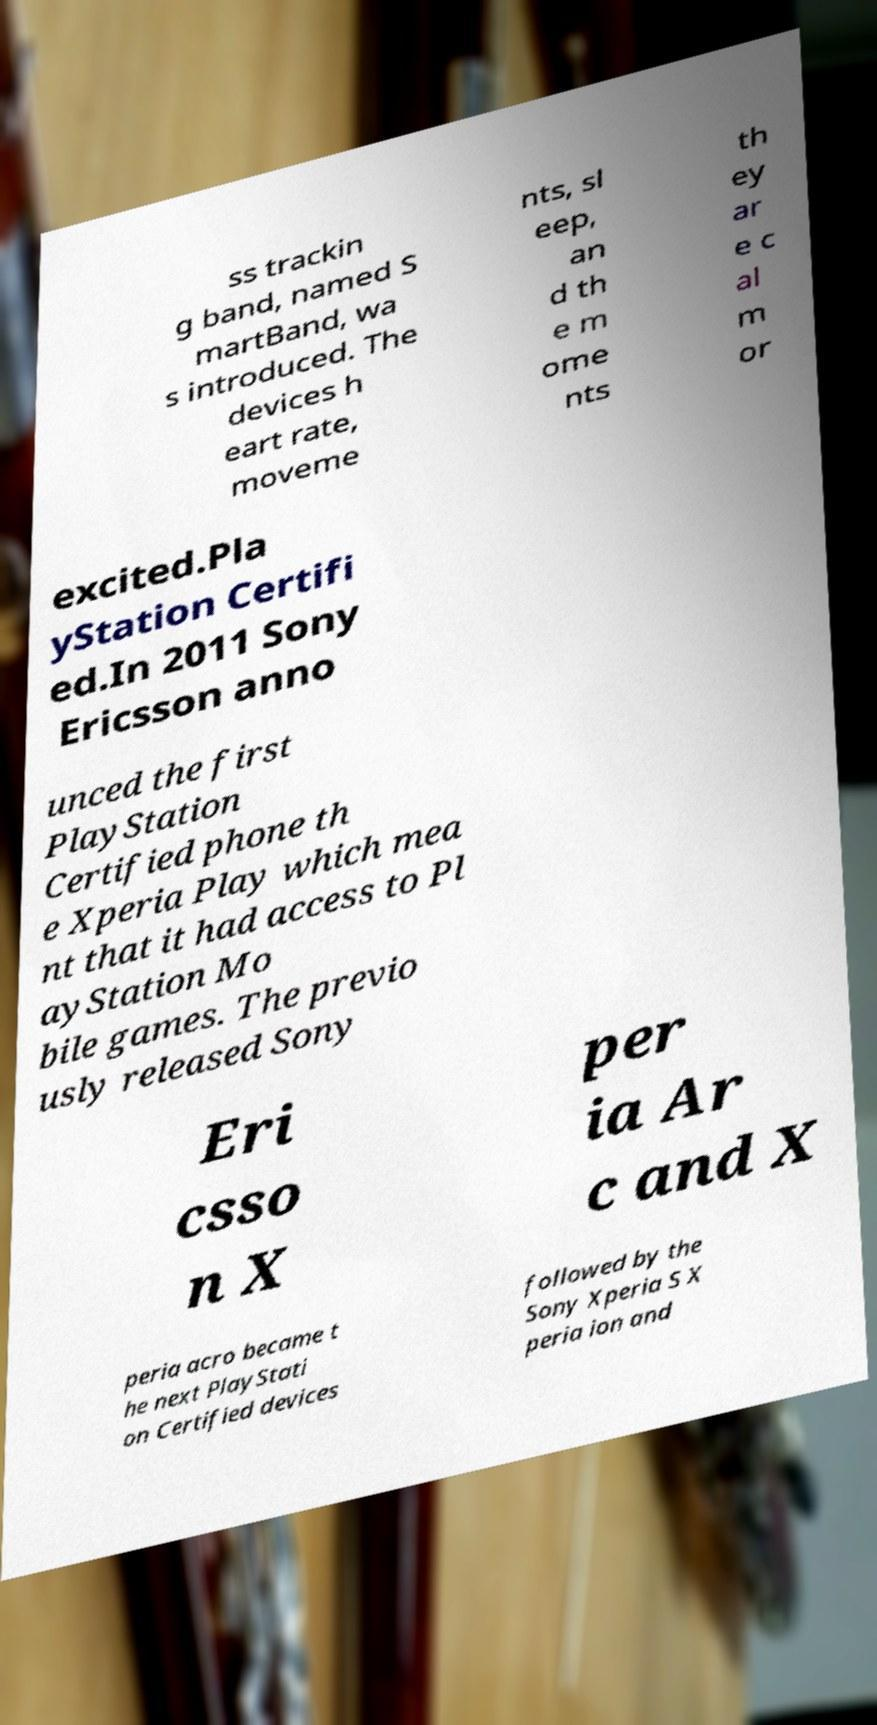Could you extract and type out the text from this image? ss trackin g band, named S martBand, wa s introduced. The devices h eart rate, moveme nts, sl eep, an d th e m ome nts th ey ar e c al m or excited.Pla yStation Certifi ed.In 2011 Sony Ericsson anno unced the first PlayStation Certified phone th e Xperia Play which mea nt that it had access to Pl ayStation Mo bile games. The previo usly released Sony Eri csso n X per ia Ar c and X peria acro became t he next PlayStati on Certified devices followed by the Sony Xperia S X peria ion and 